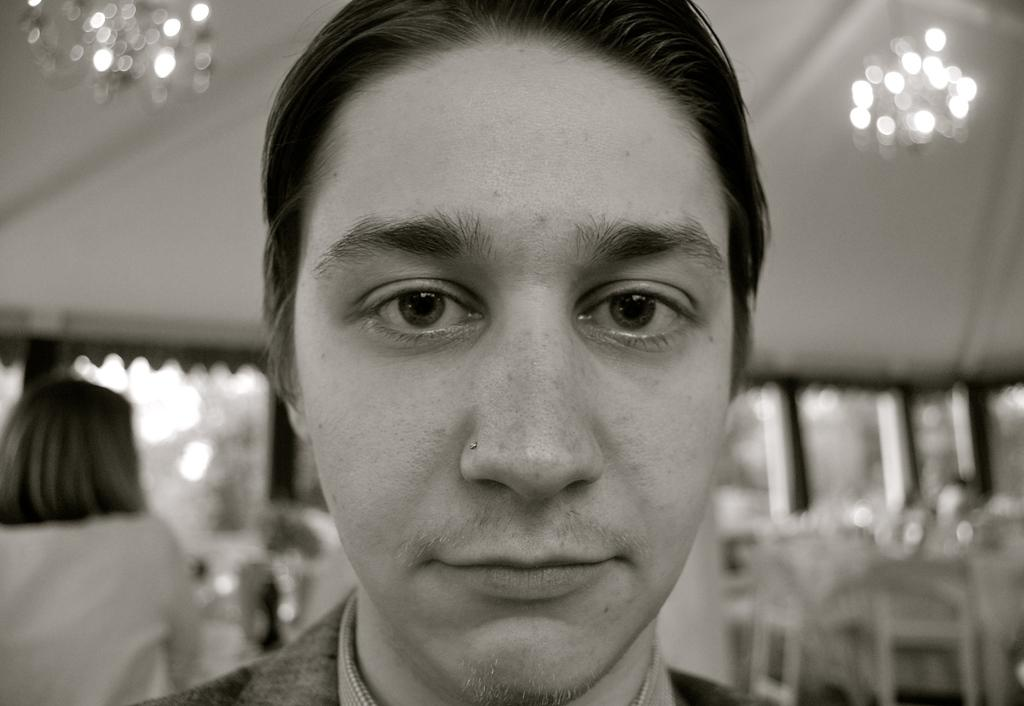What is the color scheme of the image? The image is black and white. Can you describe the main subject in the image? There is a person in the image. What is the appearance of the background in the image? The background of the image is blurred. Can you tell me how many snakes are slithering in the image? There are no snakes present in the image. What type of star can be seen shining in the image? There is no star present in the image, as it is a black and white image. 